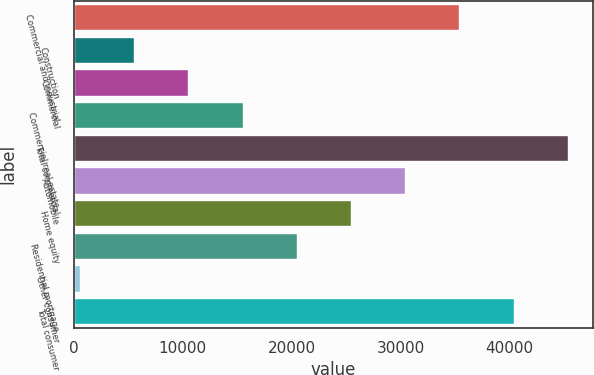Convert chart to OTSL. <chart><loc_0><loc_0><loc_500><loc_500><bar_chart><fcel>Commercial and industrial<fcel>Construction<fcel>Commercial<fcel>Commercial real estate<fcel>Total commercial<fcel>Automobile<fcel>Home equity<fcel>Residential mortgage<fcel>Other consumer<fcel>Total consumer<nl><fcel>35407.6<fcel>5540.8<fcel>10518.6<fcel>15496.4<fcel>45363.2<fcel>30429.8<fcel>25452<fcel>20474.2<fcel>563<fcel>40385.4<nl></chart> 